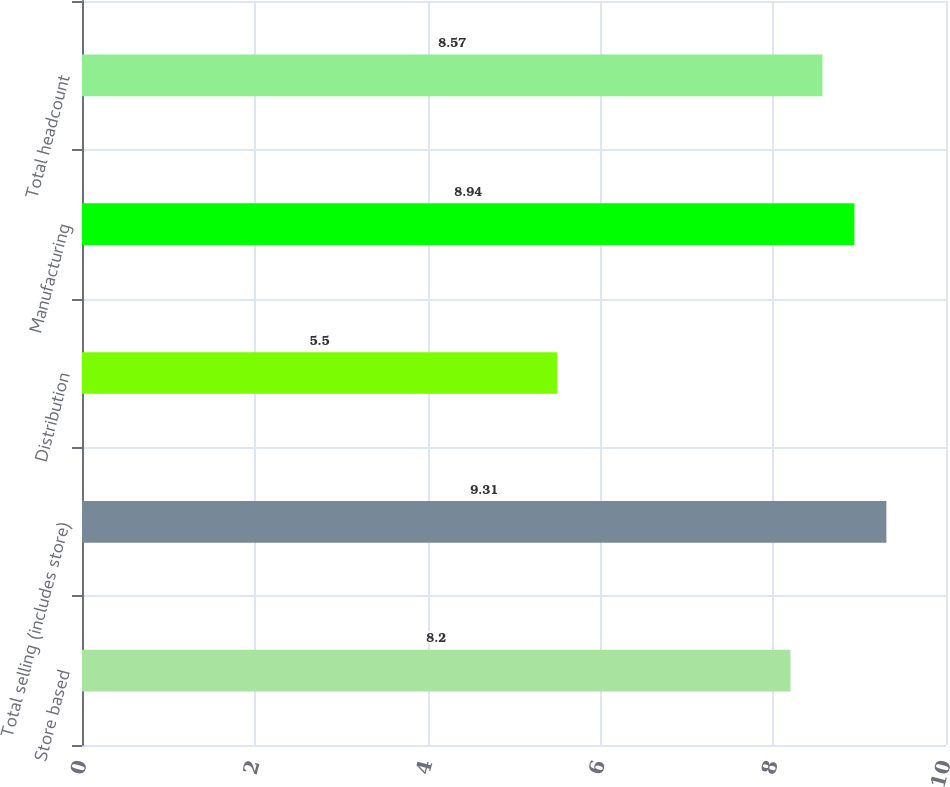Convert chart to OTSL. <chart><loc_0><loc_0><loc_500><loc_500><bar_chart><fcel>Store based<fcel>Total selling (includes store)<fcel>Distribution<fcel>Manufacturing<fcel>Total headcount<nl><fcel>8.2<fcel>9.31<fcel>5.5<fcel>8.94<fcel>8.57<nl></chart> 